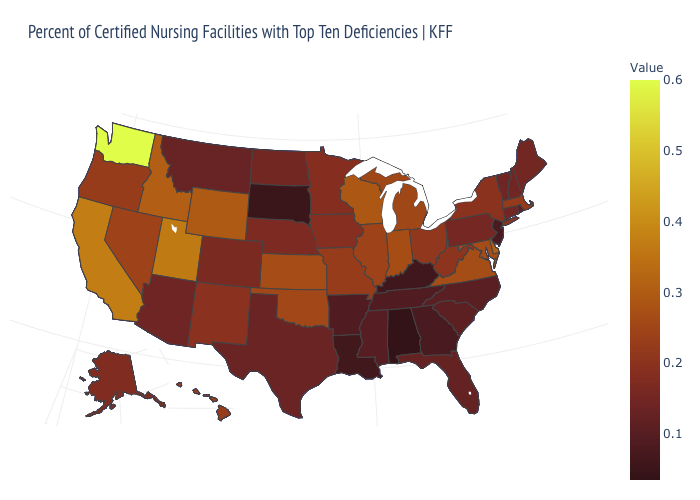Among the states that border New Jersey , does Pennsylvania have the lowest value?
Short answer required. Yes. Does Michigan have the lowest value in the USA?
Answer briefly. No. Which states have the highest value in the USA?
Write a very short answer. Washington. Which states have the highest value in the USA?
Keep it brief. Washington. Does Arizona have the lowest value in the West?
Short answer required. No. Among the states that border Wisconsin , which have the lowest value?
Quick response, please. Minnesota. Does Oklahoma have a lower value than Washington?
Keep it brief. Yes. 